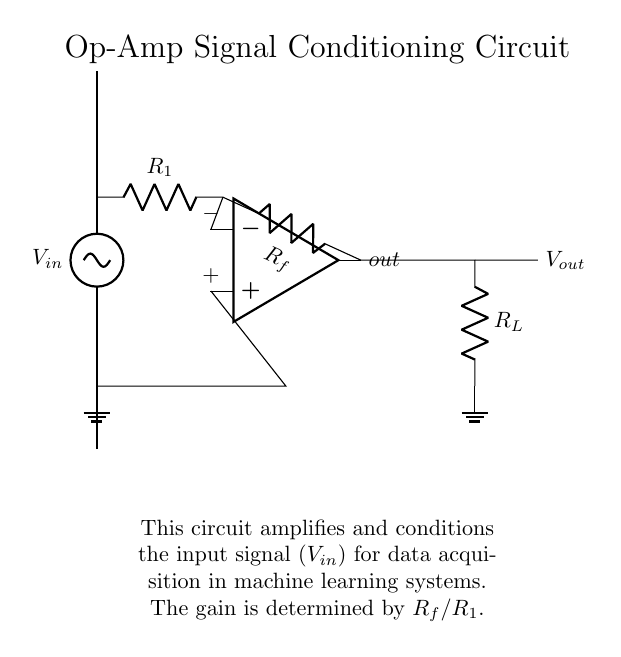What does V_in represent in this circuit? V_in is the input voltage signal that is being conditioned by the operational amplifier. It's connected to the first resistor R_1.
Answer: input voltage signal What is the function of R_f in the circuit? R_f is the feedback resistor that, along with R_1, sets the gain of the operational amplifier. The gain is calculated as R_f divided by R_1.
Answer: feedback resistor What happens to the signal after it passes through the op-amp? The signal gets amplified and conditioned, resulting in an output voltage V_out at the output of the op-amp.
Answer: amplified signal How is the gain of the circuit calculated? The gain is determined by the ratio of feedback resistor R_f to the input resistor R_1, expressed as R_f divided by R_1.
Answer: R_f/R_1 What type of amplifier is represented in the circuit? The circuit represents a non-inverting operational amplifier configuration used for signal conditioning.
Answer: non-inverting operational amplifier What is the purpose of connecting R_L in the circuit? R_L acts as the load resistor, which allows the op-amp to drive the output signal to a connected load, affecting the overall performance of the output signal.
Answer: load resistor 